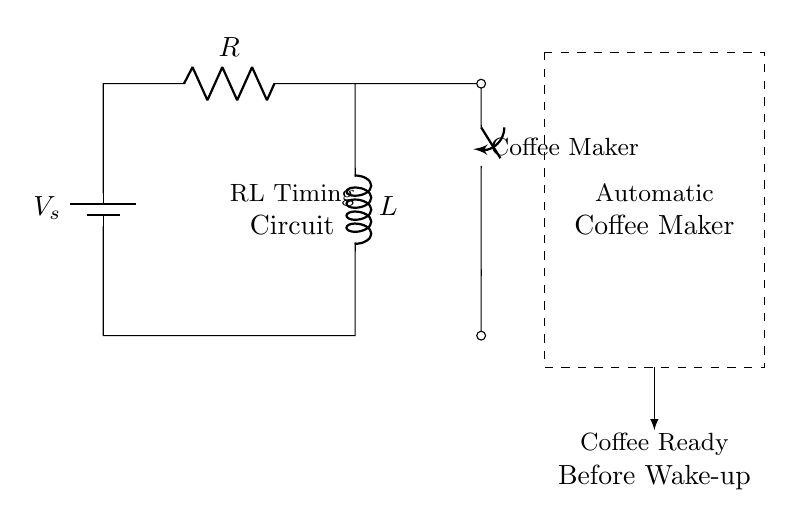What type of circuit is depicted? The circuit shown is an RL Timing Circuit, comprising a resistor and an inductor, designed for timing applications.
Answer: RL Timing Circuit What components are present in the circuit? The circuit contains a battery, a resistor, an inductor, and a switch. These are the basic components indicated by their symbols.
Answer: Battery, resistor, inductor, switch What is the function of the switch in the circuit? The switch controls the current flow to the coffee maker. When closed, it allows the inductor to charge and, subsequently, the current will actuate the coffee maker.
Answer: Current control How does the inductor affect current in the circuit? The inductor temporarily stores energy in a magnetic field when current passes through it, impacting the timing for when the coffee maker turns on. The inductance determines how quickly the current rises or falls.
Answer: Stores energy What will happen if the resistor value increases? Increasing the resistor value will slow down the charging process of the inductor, resulting in a longer delay before the coffee maker activates. This is due to the time constant, which is influenced by both the resistor and inductor values.
Answer: Longer delay How can we use this circuit to brew coffee before waking up? By adjusting the values of the resistor and inductor, the timing circuit can be set to activate the coffee maker at a specific time before the user's wake-up time. This precise timing is facilitated by the characteristic behavior of the RL circuit.
Answer: Set timing 